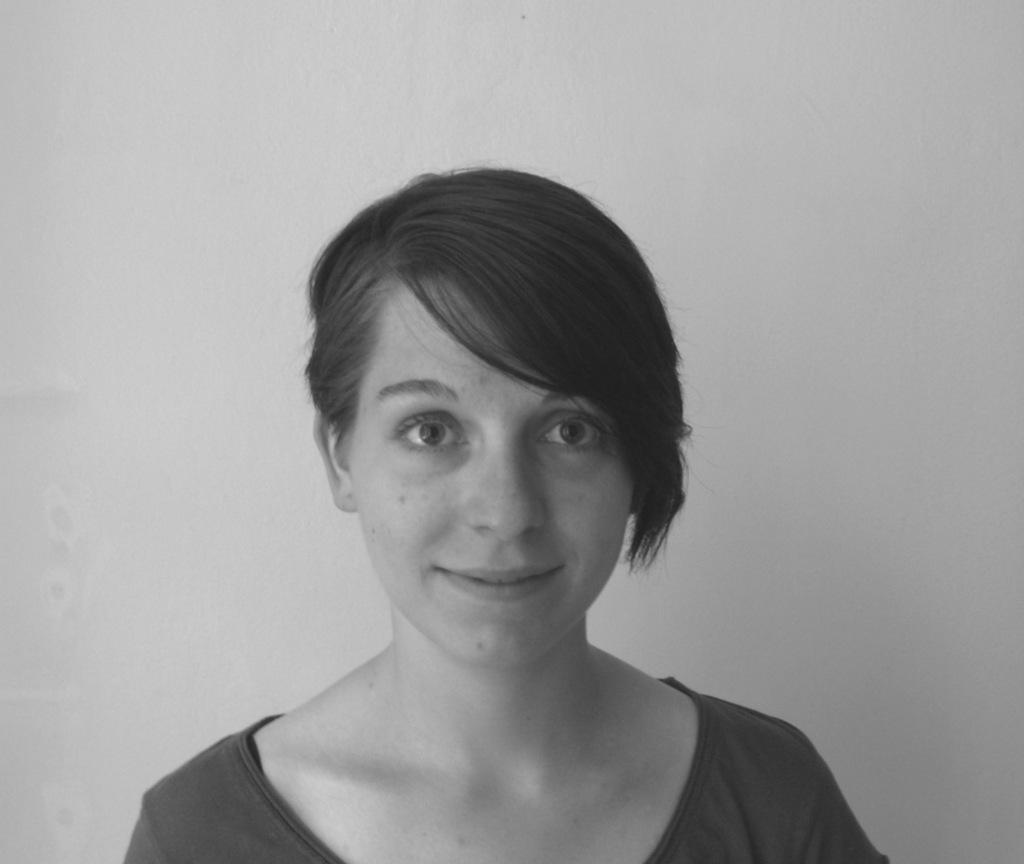What is the color scheme of the image? The image is black and white. Who or what is the main subject in the image? There is a woman in the image. What can be seen in the background of the image? There is a wall in the background of the image. How many eggs can be seen on the woman's back in the image? There are no eggs visible on the woman's back in the image, as it is a black and white image of a woman with a wall in the background. 